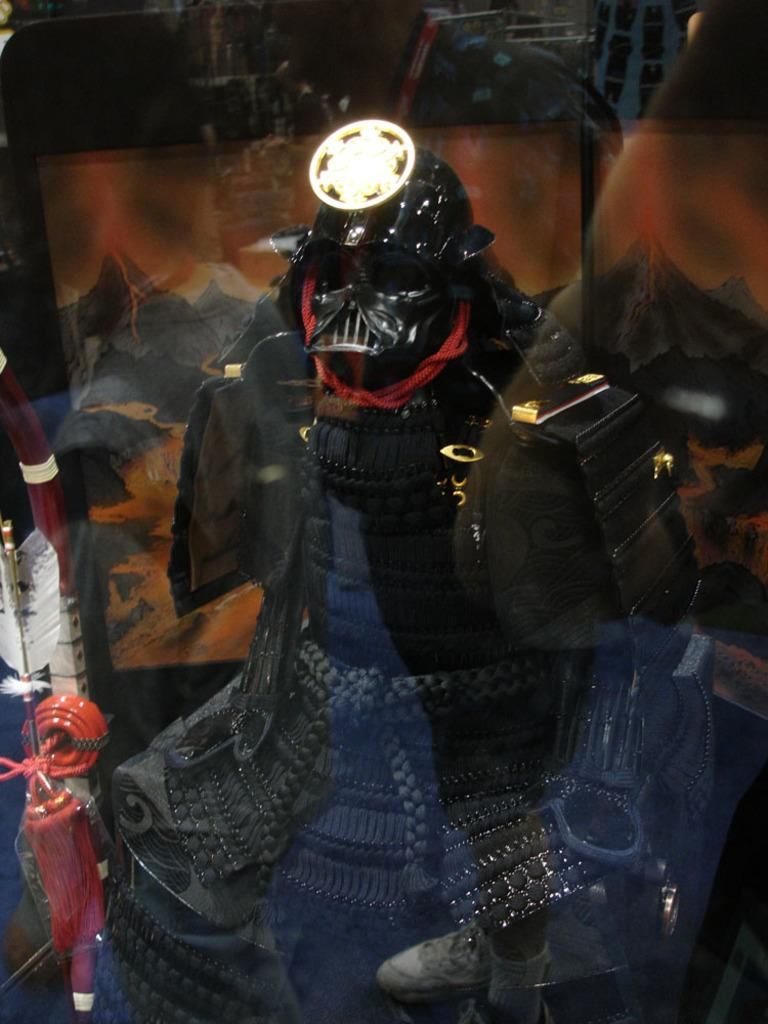What type of toy is present in the image? There is a black color robotic toy in the image. How is the robotic toy being displayed or protected in the image? The robotic toy is kept under a glass. What type of throne is the robotic toy sitting on in the image? There is no throne present in the image; the robotic toy is kept under a glass. What color is the chalk used to draw around the glass in the image? There is no chalk or drawing around the glass in the image. 